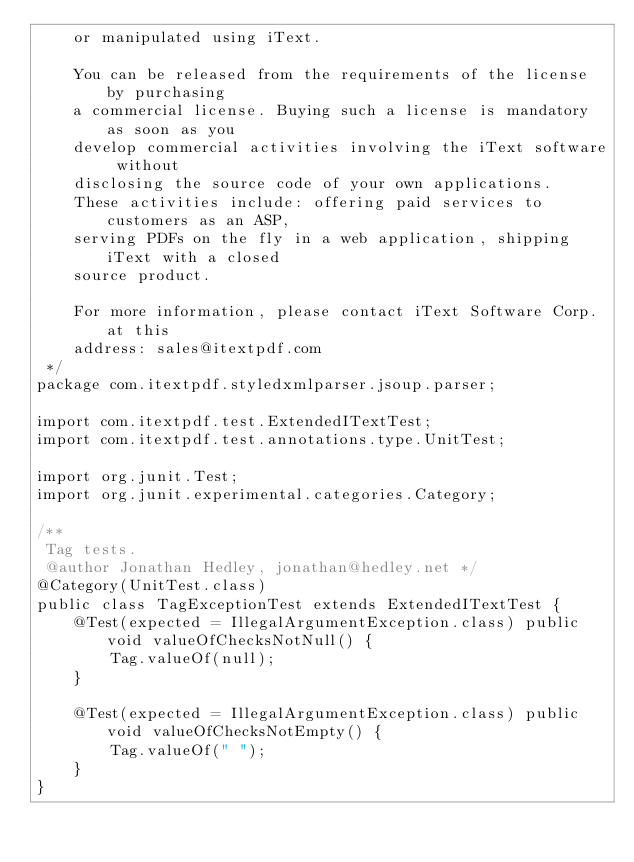<code> <loc_0><loc_0><loc_500><loc_500><_Java_>    or manipulated using iText.

    You can be released from the requirements of the license by purchasing
    a commercial license. Buying such a license is mandatory as soon as you
    develop commercial activities involving the iText software without
    disclosing the source code of your own applications.
    These activities include: offering paid services to customers as an ASP,
    serving PDFs on the fly in a web application, shipping iText with a closed
    source product.

    For more information, please contact iText Software Corp. at this
    address: sales@itextpdf.com
 */
package com.itextpdf.styledxmlparser.jsoup.parser;

import com.itextpdf.test.ExtendedITextTest;
import com.itextpdf.test.annotations.type.UnitTest;

import org.junit.Test;
import org.junit.experimental.categories.Category;

/**
 Tag tests.
 @author Jonathan Hedley, jonathan@hedley.net */
@Category(UnitTest.class)
public class TagExceptionTest extends ExtendedITextTest {
    @Test(expected = IllegalArgumentException.class) public void valueOfChecksNotNull() {
        Tag.valueOf(null);
    }

    @Test(expected = IllegalArgumentException.class) public void valueOfChecksNotEmpty() {
        Tag.valueOf(" ");
    }
}
</code> 